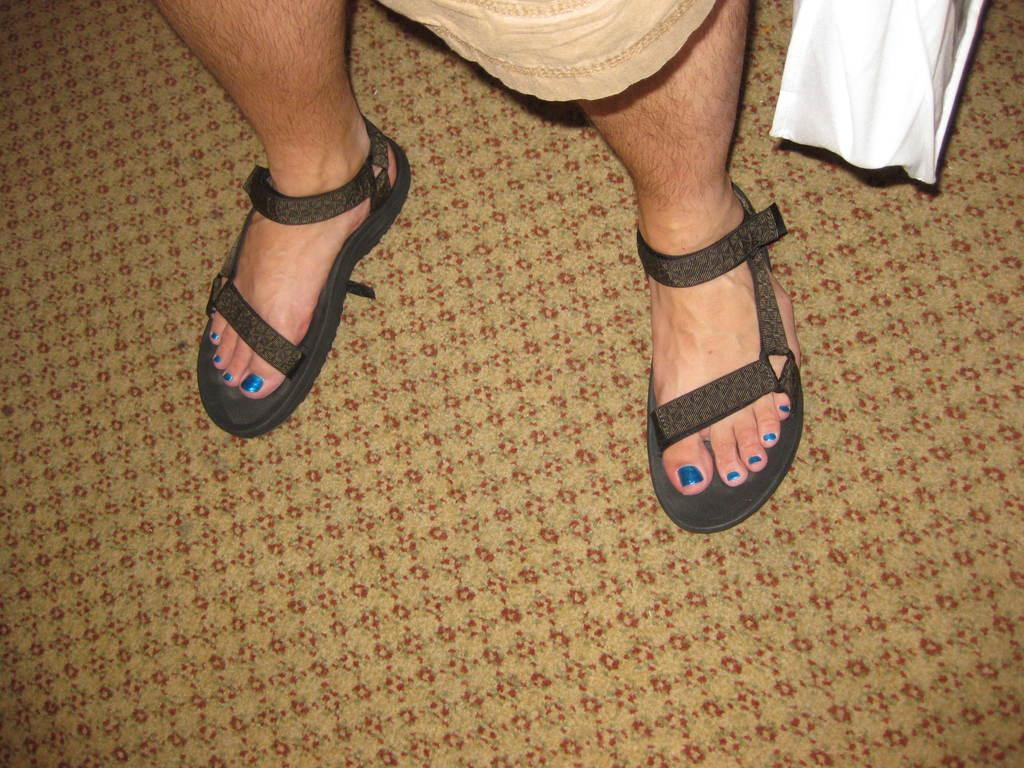What part of a person's body can be seen in the image? There is a person's leg visible in the image. How is the leg covered in the image? The leg is covered with a chapel. What can be seen on the right side of the image? There is a white cloth on the right side of the image. What type of spoon can be seen in the aftermath of the event in the image? There is no spoon or event present in the image; it only shows a person's leg covered with a chapel and a white cloth on the right side. 